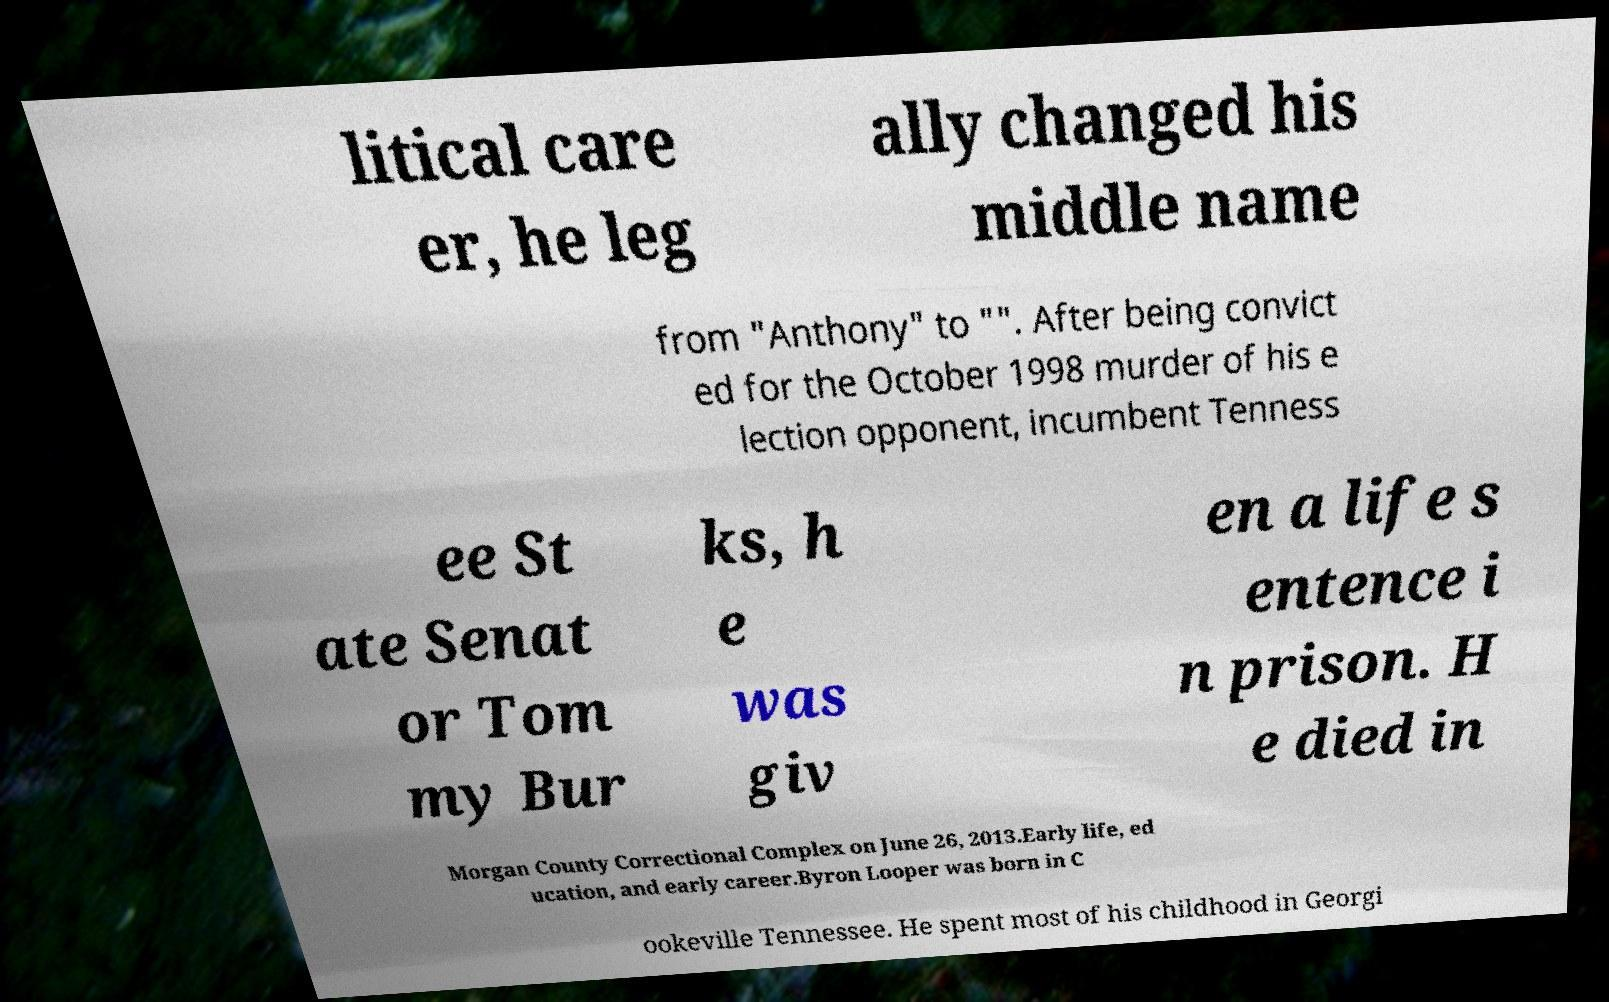I need the written content from this picture converted into text. Can you do that? litical care er, he leg ally changed his middle name from "Anthony" to "". After being convict ed for the October 1998 murder of his e lection opponent, incumbent Tenness ee St ate Senat or Tom my Bur ks, h e was giv en a life s entence i n prison. H e died in Morgan County Correctional Complex on June 26, 2013.Early life, ed ucation, and early career.Byron Looper was born in C ookeville Tennessee. He spent most of his childhood in Georgi 